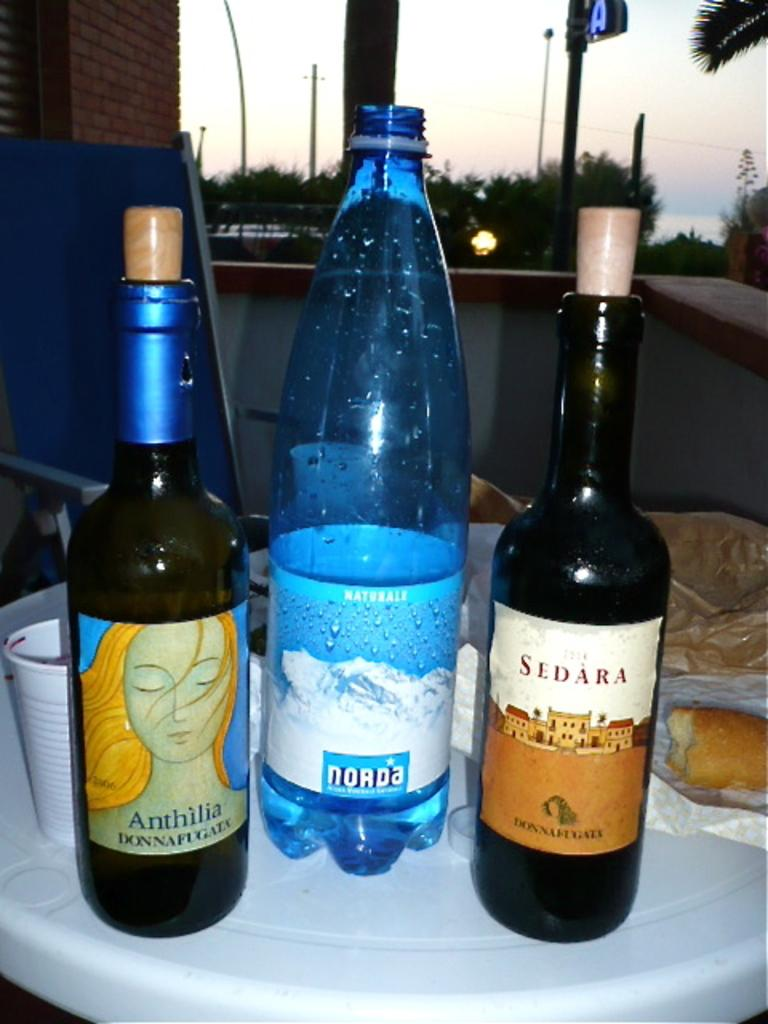<image>
Relay a brief, clear account of the picture shown. A bottle of Sedara wine and Anthilia wine are on a serving platter with water. 